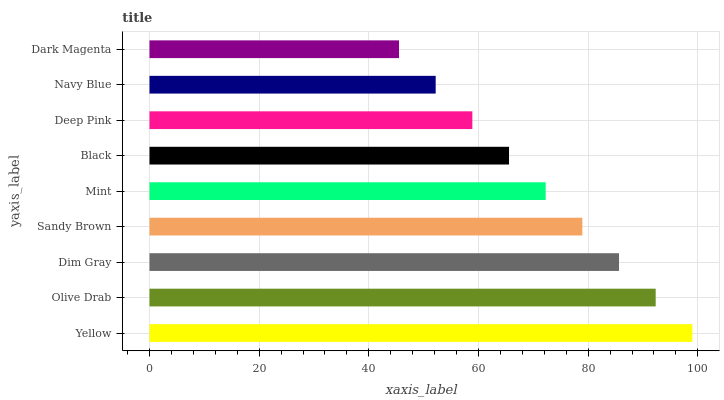Is Dark Magenta the minimum?
Answer yes or no. Yes. Is Yellow the maximum?
Answer yes or no. Yes. Is Olive Drab the minimum?
Answer yes or no. No. Is Olive Drab the maximum?
Answer yes or no. No. Is Yellow greater than Olive Drab?
Answer yes or no. Yes. Is Olive Drab less than Yellow?
Answer yes or no. Yes. Is Olive Drab greater than Yellow?
Answer yes or no. No. Is Yellow less than Olive Drab?
Answer yes or no. No. Is Mint the high median?
Answer yes or no. Yes. Is Mint the low median?
Answer yes or no. Yes. Is Olive Drab the high median?
Answer yes or no. No. Is Yellow the low median?
Answer yes or no. No. 